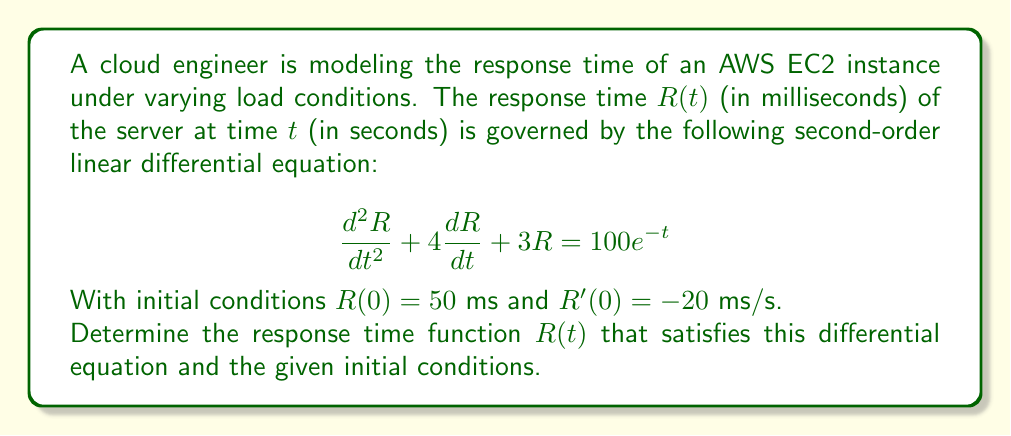Provide a solution to this math problem. Let's solve this step-by-step:

1) The general form of a second-order linear differential equation is:
   $$ay'' + by' + cy = f(t)$$
   
   In our case, $a=1$, $b=4$, $c=3$, and $f(t) = 100e^{-t}$.

2) The characteristic equation is:
   $$r^2 + 4r + 3 = 0$$

3) Solving this quadratic equation:
   $$(r+1)(r+3) = 0$$
   $r = -1$ or $r = -3$

4) The complementary solution is:
   $$R_c(t) = C_1e^{-t} + C_2e^{-3t}$$

5) For the particular solution, we guess:
   $$R_p(t) = Ae^{-t}$$

6) Substituting this into the original equation:
   $$A(-1)^2e^{-t} + 4A(-1)e^{-t} + 3Ae^{-t} = 100e^{-t}$$
   $$Ae^{-t} - 4Ae^{-t} + 3Ae^{-t} = 100e^{-t}$$
   $$0 = 100e^{-t}$$
   $$A = 100$$

7) The general solution is:
   $$R(t) = C_1e^{-t} + C_2e^{-3t} + 100e^{-t}$$

8) Using the initial conditions:
   $R(0) = 50$: $C_1 + C_2 + 100 = 50$
   $R'(0) = -20$: $-C_1 - 3C_2 - 100 = -20$

9) Solving these equations:
   $C_1 = -75$, $C_2 = 25$

10) Therefore, the final solution is:
    $$R(t) = -75e^{-t} + 25e^{-3t} + 100e^{-t}$$
    $$R(t) = 25e^{-t} + 25e^{-3t}$$
Answer: $R(t) = 25e^{-t} + 25e^{-3t}$ 